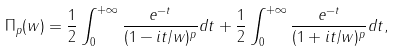Convert formula to latex. <formula><loc_0><loc_0><loc_500><loc_500>\Pi _ { p } ( w ) = \frac { 1 } { 2 } \int _ { 0 } ^ { + \infty } \frac { e ^ { - t } } { ( 1 - i t / w ) ^ { p } } d t + \frac { 1 } { 2 } \int _ { 0 } ^ { + \infty } \frac { e ^ { - t } } { ( 1 + i t / w ) ^ { p } } d t ,</formula> 